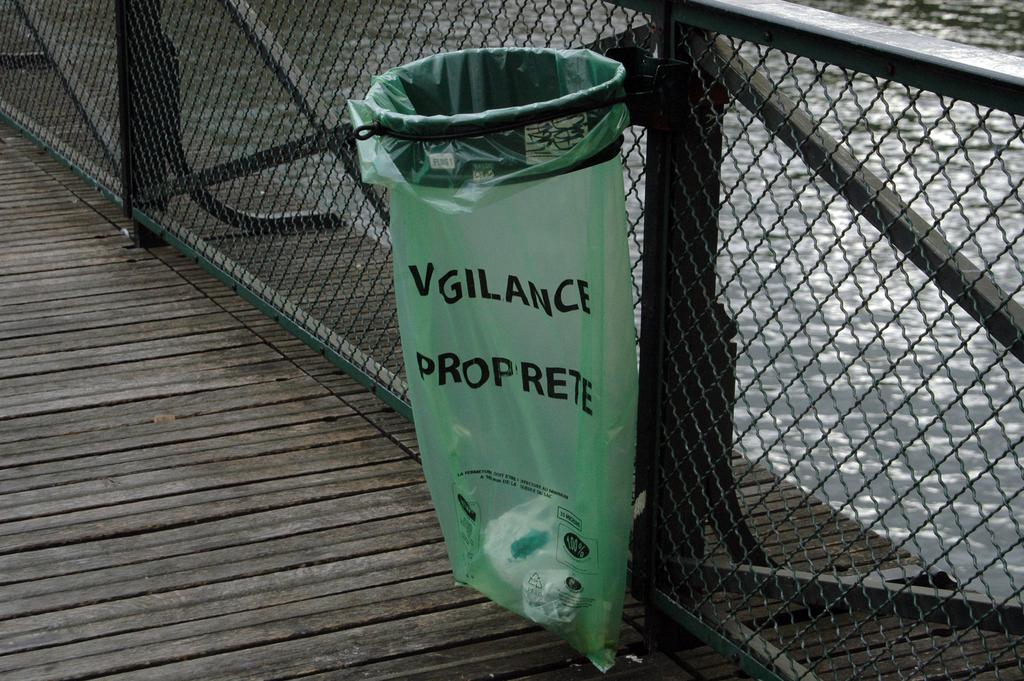What words are on the green bin bag?
Provide a succinct answer. Vigilance proprete. 